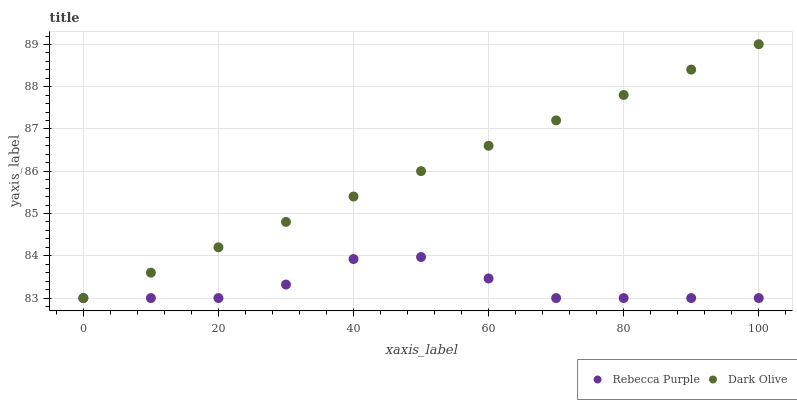Does Rebecca Purple have the minimum area under the curve?
Answer yes or no. Yes. Does Dark Olive have the maximum area under the curve?
Answer yes or no. Yes. Does Rebecca Purple have the maximum area under the curve?
Answer yes or no. No. Is Dark Olive the smoothest?
Answer yes or no. Yes. Is Rebecca Purple the roughest?
Answer yes or no. Yes. Is Rebecca Purple the smoothest?
Answer yes or no. No. Does Dark Olive have the lowest value?
Answer yes or no. Yes. Does Dark Olive have the highest value?
Answer yes or no. Yes. Does Rebecca Purple have the highest value?
Answer yes or no. No. Does Rebecca Purple intersect Dark Olive?
Answer yes or no. Yes. Is Rebecca Purple less than Dark Olive?
Answer yes or no. No. Is Rebecca Purple greater than Dark Olive?
Answer yes or no. No. 